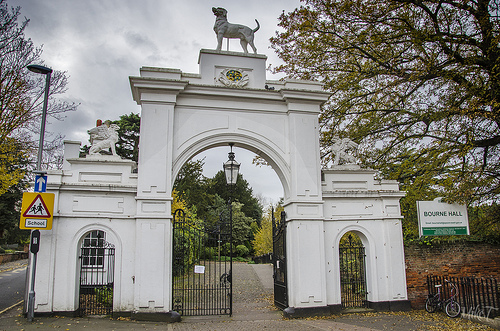<image>
Can you confirm if the pole is behind the building? No. The pole is not behind the building. From this viewpoint, the pole appears to be positioned elsewhere in the scene. 